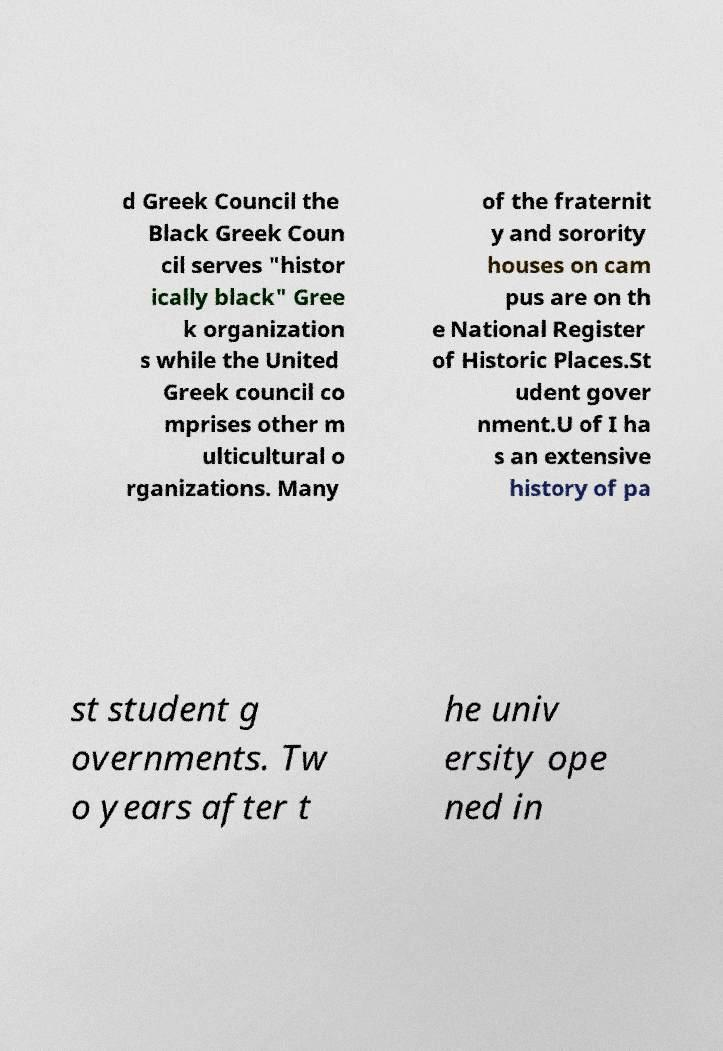Please identify and transcribe the text found in this image. d Greek Council the Black Greek Coun cil serves "histor ically black" Gree k organization s while the United Greek council co mprises other m ulticultural o rganizations. Many of the fraternit y and sorority houses on cam pus are on th e National Register of Historic Places.St udent gover nment.U of I ha s an extensive history of pa st student g overnments. Tw o years after t he univ ersity ope ned in 